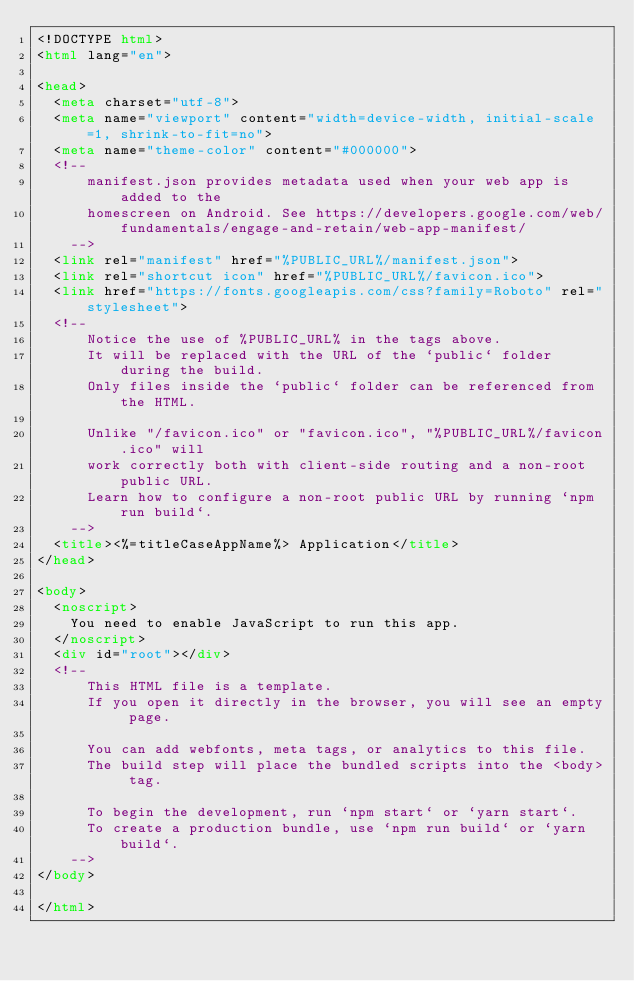<code> <loc_0><loc_0><loc_500><loc_500><_HTML_><!DOCTYPE html>
<html lang="en">

<head>
  <meta charset="utf-8">
  <meta name="viewport" content="width=device-width, initial-scale=1, shrink-to-fit=no">
  <meta name="theme-color" content="#000000">
  <!--
      manifest.json provides metadata used when your web app is added to the
      homescreen on Android. See https://developers.google.com/web/fundamentals/engage-and-retain/web-app-manifest/
    -->
  <link rel="manifest" href="%PUBLIC_URL%/manifest.json">
  <link rel="shortcut icon" href="%PUBLIC_URL%/favicon.ico">
  <link href="https://fonts.googleapis.com/css?family=Roboto" rel="stylesheet">
  <!--
      Notice the use of %PUBLIC_URL% in the tags above.
      It will be replaced with the URL of the `public` folder during the build.
      Only files inside the `public` folder can be referenced from the HTML.

      Unlike "/favicon.ico" or "favicon.ico", "%PUBLIC_URL%/favicon.ico" will
      work correctly both with client-side routing and a non-root public URL.
      Learn how to configure a non-root public URL by running `npm run build`.
    -->
  <title><%=titleCaseAppName%> Application</title>
</head>

<body>
  <noscript>
    You need to enable JavaScript to run this app.
  </noscript>
  <div id="root"></div>
  <!--
      This HTML file is a template.
      If you open it directly in the browser, you will see an empty page.

      You can add webfonts, meta tags, or analytics to this file.
      The build step will place the bundled scripts into the <body> tag.

      To begin the development, run `npm start` or `yarn start`.
      To create a production bundle, use `npm run build` or `yarn build`.
    -->
</body>

</html></code> 